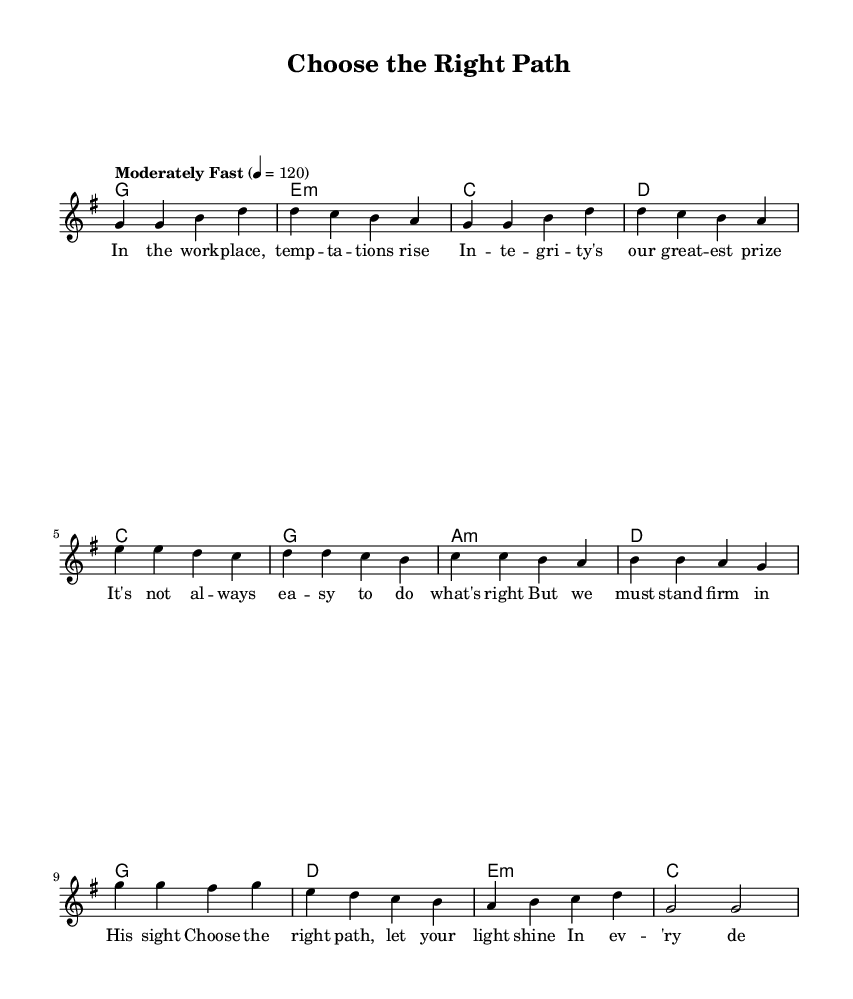What is the key signature of this music? The key signature is G major, which has one sharp (F#). This can be determined from the global section of the LilyPond code where the key is explicitly defined.
Answer: G major What is the time signature of this music? The time signature is 4/4, indicated in the global section of the code as well. This shows that there are four beats per measure, and the quarter note gets one beat.
Answer: 4/4 What is the tempo marking of the piece? The tempo marking is "Moderately Fast," indicated in the global section. It also specifies the tempo of 120 beats per minute. This means the piece should be played at a moderate speed.
Answer: Moderately fast How many measures are in the melody section? There are eight measures in the melody section. This can be counted by looking through the melody notation section where each group of notes separated by vertical bars represents a measure.
Answer: Eight What is the main theme of the lyrics? The main theme of the lyrics emphasizes integrity and making ethical decisions in the workplace, which is suggested by phrases mentioning temptations, integrity as a prize, and choosing the right path. This theme is derived from the lyrics provided in the verse section of the code.
Answer: Integrity What is the first chord in the song? The first chord in the song is G major, as indicated in the harmonies section of the code. This chord aligns with the melody, reflecting the tonal center throughout the verse.
Answer: G major What do the lyrics suggest about decision-making? The lyrics suggest that decision-making should be guided by integrity and a focus on ethics, emphasizing the importance of keeping God in mind during choices in the workplace as derived from the themes in the verse.
Answer: Ethical decision-making 